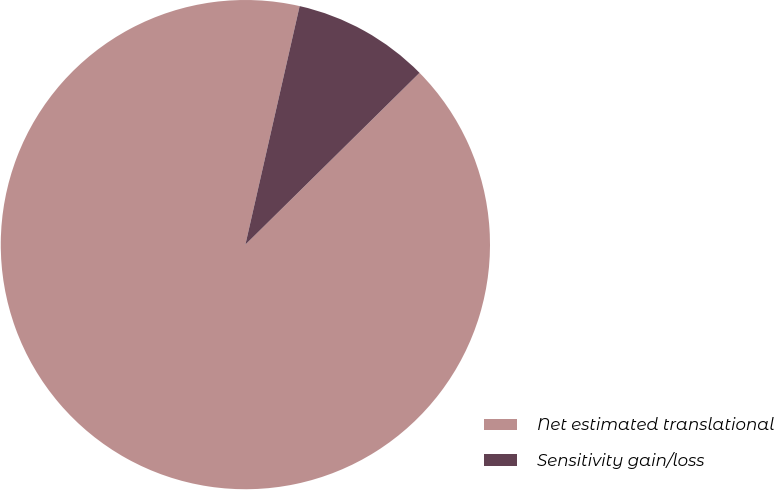Convert chart to OTSL. <chart><loc_0><loc_0><loc_500><loc_500><pie_chart><fcel>Net estimated translational<fcel>Sensitivity gain/loss<nl><fcel>90.95%<fcel>9.05%<nl></chart> 